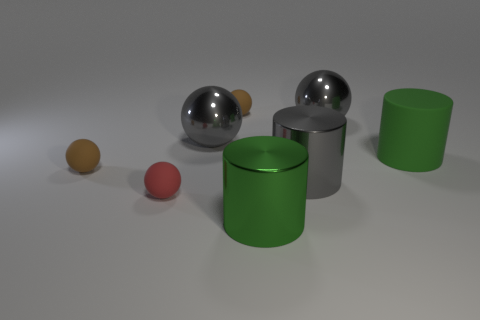What color is the tiny object that is right of the gray object that is to the left of the tiny object behind the large matte thing?
Provide a short and direct response. Brown. Is the material of the red sphere the same as the large gray cylinder?
Your answer should be very brief. No. Is there a yellow ball of the same size as the red rubber ball?
Provide a succinct answer. No. What material is the other green object that is the same size as the green metallic thing?
Provide a succinct answer. Rubber. Are there any other large green objects of the same shape as the big rubber thing?
Provide a succinct answer. Yes. What shape is the large green object that is right of the big green shiny object?
Ensure brevity in your answer.  Cylinder. How many blue metallic things are there?
Offer a very short reply. 0. What color is the big thing that is the same material as the tiny red object?
Your answer should be compact. Green. How many large objects are red things or purple matte blocks?
Give a very brief answer. 0. There is a tiny red thing; what number of large gray shiny spheres are behind it?
Provide a succinct answer. 2. 